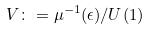Convert formula to latex. <formula><loc_0><loc_0><loc_500><loc_500>V \colon = \mu ^ { - 1 } ( \epsilon ) / U ( 1 )</formula> 